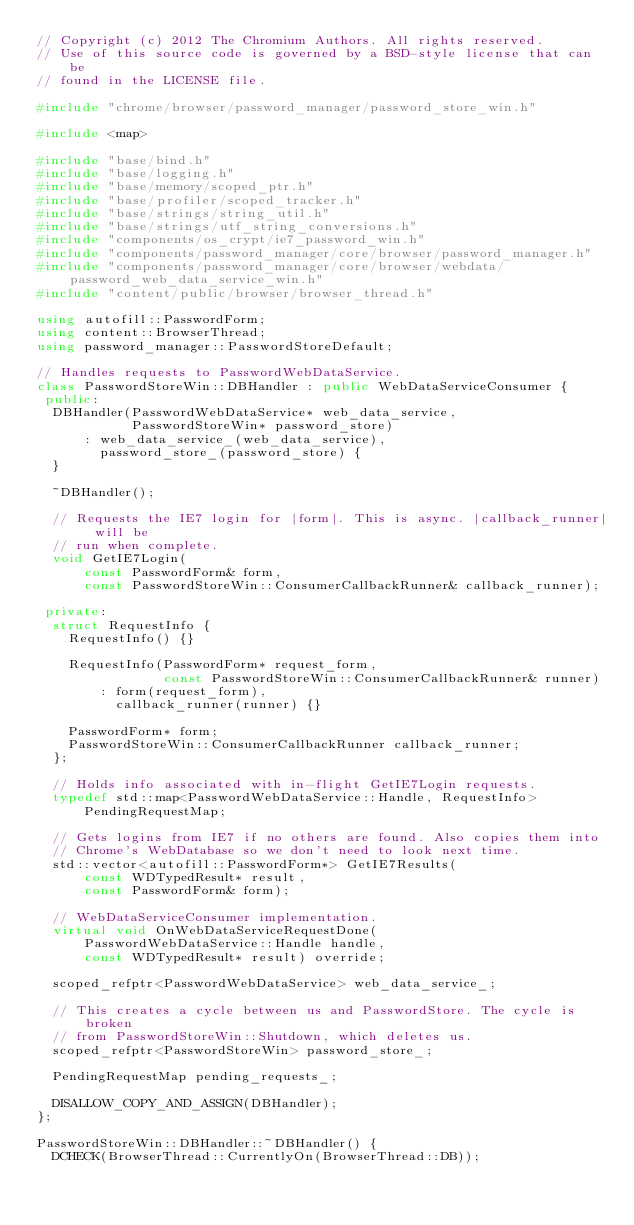Convert code to text. <code><loc_0><loc_0><loc_500><loc_500><_C++_>// Copyright (c) 2012 The Chromium Authors. All rights reserved.
// Use of this source code is governed by a BSD-style license that can be
// found in the LICENSE file.

#include "chrome/browser/password_manager/password_store_win.h"

#include <map>

#include "base/bind.h"
#include "base/logging.h"
#include "base/memory/scoped_ptr.h"
#include "base/profiler/scoped_tracker.h"
#include "base/strings/string_util.h"
#include "base/strings/utf_string_conversions.h"
#include "components/os_crypt/ie7_password_win.h"
#include "components/password_manager/core/browser/password_manager.h"
#include "components/password_manager/core/browser/webdata/password_web_data_service_win.h"
#include "content/public/browser/browser_thread.h"

using autofill::PasswordForm;
using content::BrowserThread;
using password_manager::PasswordStoreDefault;

// Handles requests to PasswordWebDataService.
class PasswordStoreWin::DBHandler : public WebDataServiceConsumer {
 public:
  DBHandler(PasswordWebDataService* web_data_service,
            PasswordStoreWin* password_store)
      : web_data_service_(web_data_service),
        password_store_(password_store) {
  }

  ~DBHandler();

  // Requests the IE7 login for |form|. This is async. |callback_runner| will be
  // run when complete.
  void GetIE7Login(
      const PasswordForm& form,
      const PasswordStoreWin::ConsumerCallbackRunner& callback_runner);

 private:
  struct RequestInfo {
    RequestInfo() {}

    RequestInfo(PasswordForm* request_form,
                const PasswordStoreWin::ConsumerCallbackRunner& runner)
        : form(request_form),
          callback_runner(runner) {}

    PasswordForm* form;
    PasswordStoreWin::ConsumerCallbackRunner callback_runner;
  };

  // Holds info associated with in-flight GetIE7Login requests.
  typedef std::map<PasswordWebDataService::Handle, RequestInfo>
      PendingRequestMap;

  // Gets logins from IE7 if no others are found. Also copies them into
  // Chrome's WebDatabase so we don't need to look next time.
  std::vector<autofill::PasswordForm*> GetIE7Results(
      const WDTypedResult* result,
      const PasswordForm& form);

  // WebDataServiceConsumer implementation.
  virtual void OnWebDataServiceRequestDone(
      PasswordWebDataService::Handle handle,
      const WDTypedResult* result) override;

  scoped_refptr<PasswordWebDataService> web_data_service_;

  // This creates a cycle between us and PasswordStore. The cycle is broken
  // from PasswordStoreWin::Shutdown, which deletes us.
  scoped_refptr<PasswordStoreWin> password_store_;

  PendingRequestMap pending_requests_;

  DISALLOW_COPY_AND_ASSIGN(DBHandler);
};

PasswordStoreWin::DBHandler::~DBHandler() {
  DCHECK(BrowserThread::CurrentlyOn(BrowserThread::DB));</code> 